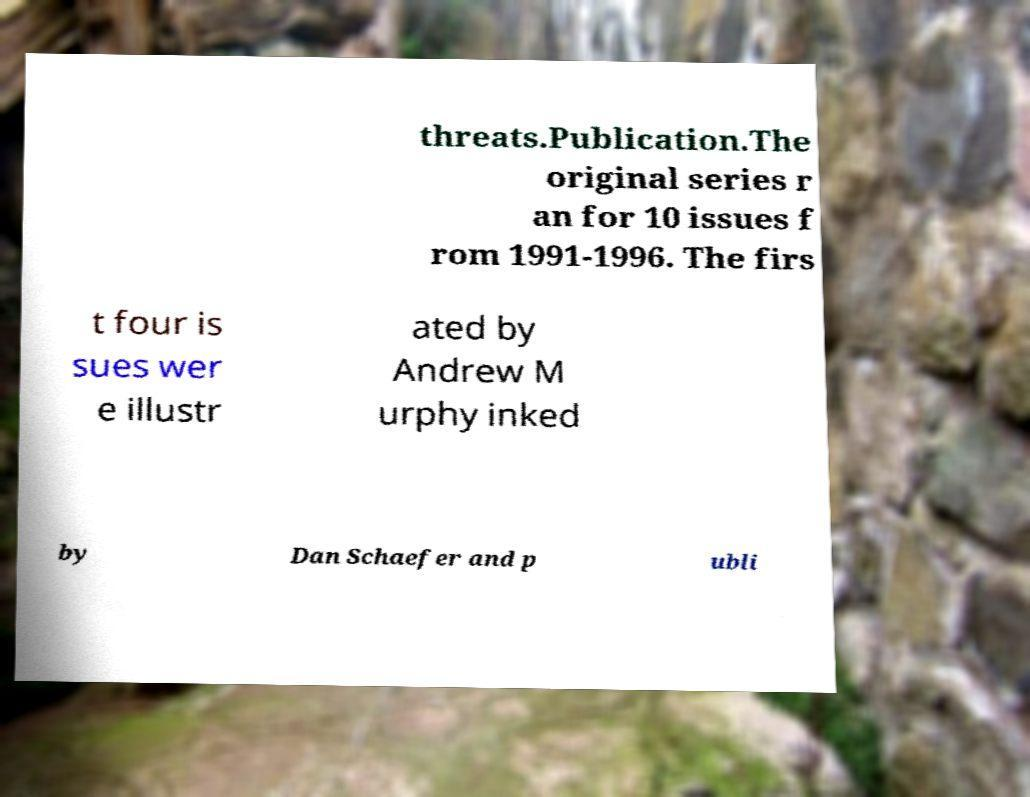What messages or text are displayed in this image? I need them in a readable, typed format. threats.Publication.The original series r an for 10 issues f rom 1991-1996. The firs t four is sues wer e illustr ated by Andrew M urphy inked by Dan Schaefer and p ubli 